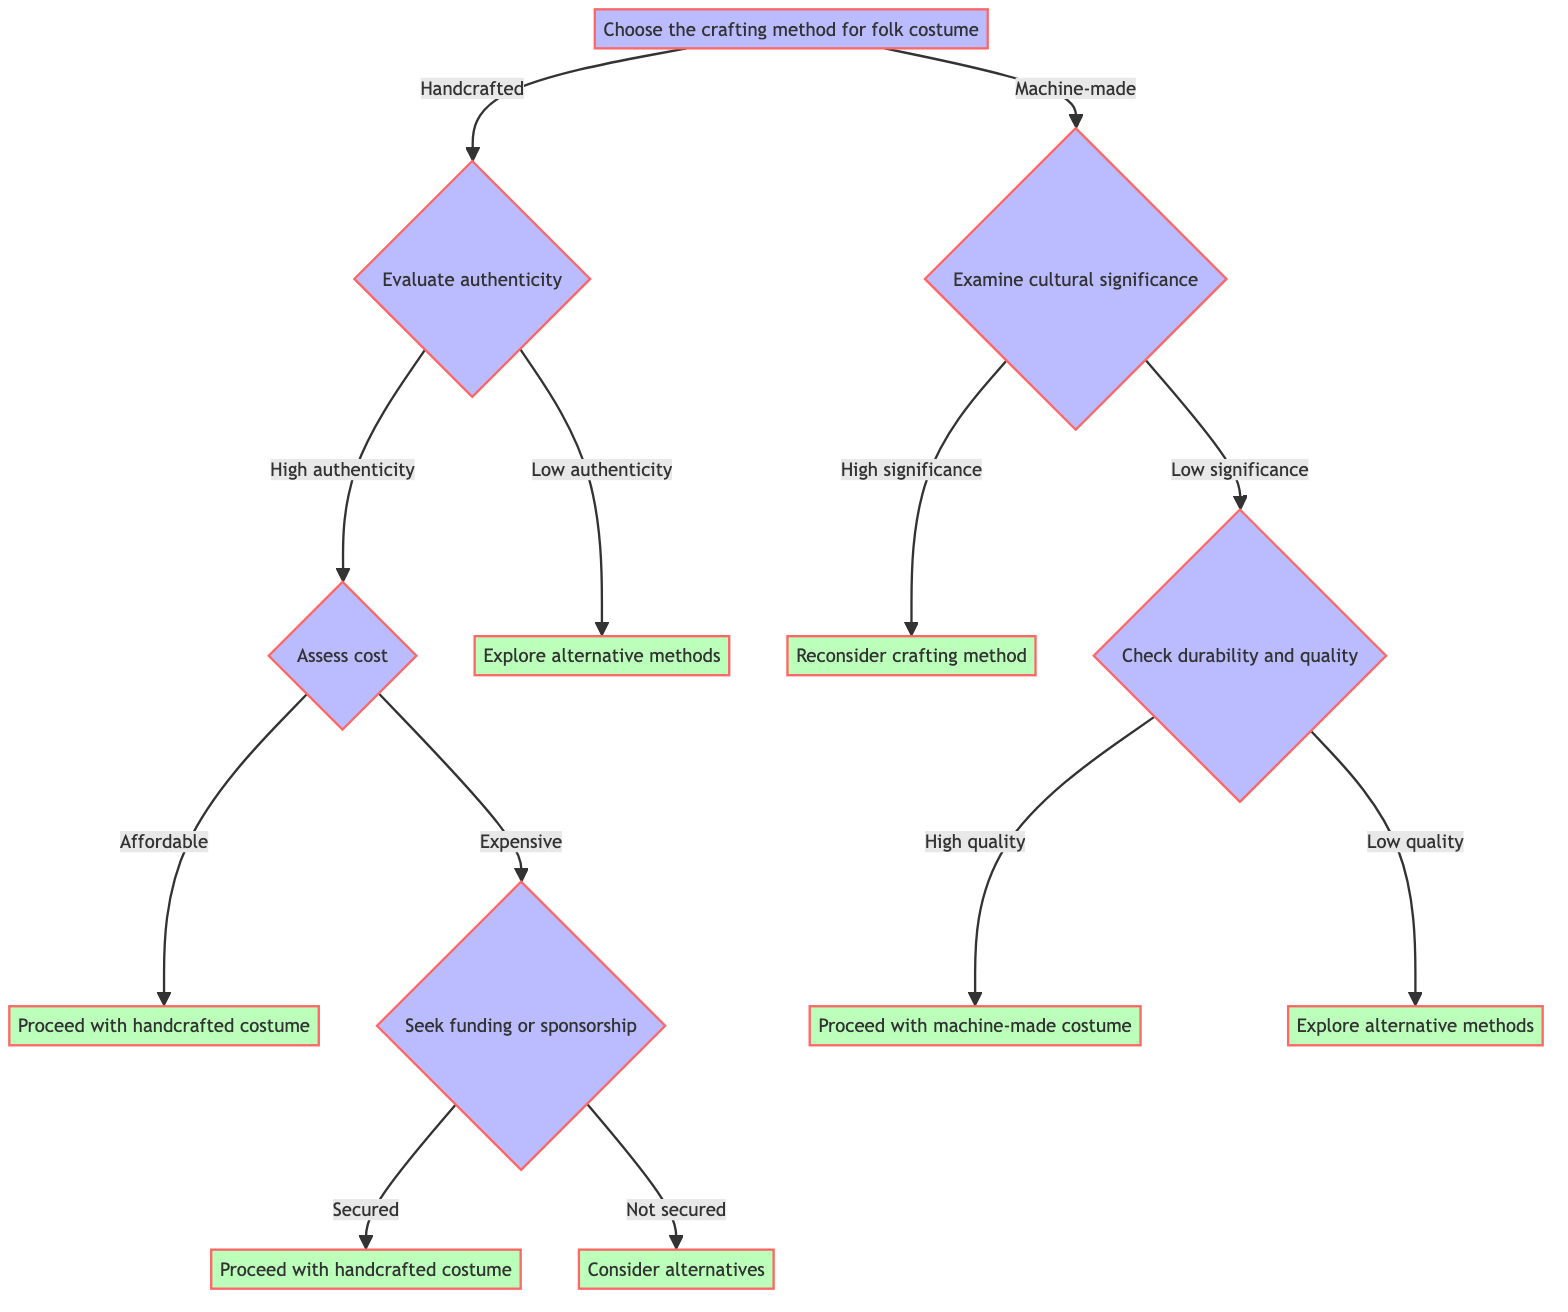What is the first decision point in the diagram? The first decision point is to choose the crafting method for the folk costume. This is indicated at the top of the diagram, where the initial split occurs between "Handcrafted" and "Machine-made."
Answer: Choose the crafting method for folk costume How many options are presented at the initial decision point? At the initial decision point, there are two options presented: "Handcrafted" and "Machine-made." This can be seen as the flow splits into these two branches.
Answer: 2 What happens if the authenticity is evaluated as low? If the authenticity is evaluated as low, the result is to explore alternative methods. This is a direct outcome from the decision point that follows evaluating authenticity.
Answer: Explore alternative methods If a handcrafted costume is expensive and funding is not secured, what is the next step? If a handcrafted costume is expensive and funding is not secured, the next step is to consider alternatives. This follows the decision path from the cost assessment to seeking funding and the subsequent result if funding is not secured.
Answer: Consider alternatives What result follows if the cultural significance of a machine-made costume is high? If the cultural significance of a machine-made costume is high, the result is to reconsider the crafting method. This is shown in the path that branches off after examining cultural significance.
Answer: Reconsider crafting method How many outcomes lead to "Proceed with handcrafted costume"? There are two pathways that lead to "Proceed with handcrafted costume": one from affordable cost after evaluating high authenticity and another from secured funding after an expensive cost. Counting these two distinct paths gives the total outcomes that lead to this result.
Answer: 2 What should be checked after determining low significance for a machine-made costume? After determining low significance for a machine-made costume, the next step is to check durability and quality. This follows directly from the decision of low significance in the flow.
Answer: Check durability and quality What is the result if, after cost assessment, the handcrafted option is affordable? If the handcrafted option is affordable after cost assessment, the result is to proceed with the handcrafted costume. This result is directly connected to the cost decision node in the diagram.
Answer: Proceed with handcrafted costume What needs to be assessed after evaluating high authenticity for handcrafted costumes? After evaluating high authenticity for handcrafted costumes, the next step is to assess cost. This is the following decision point branching out from the high authenticity evaluation.
Answer: Assess cost 